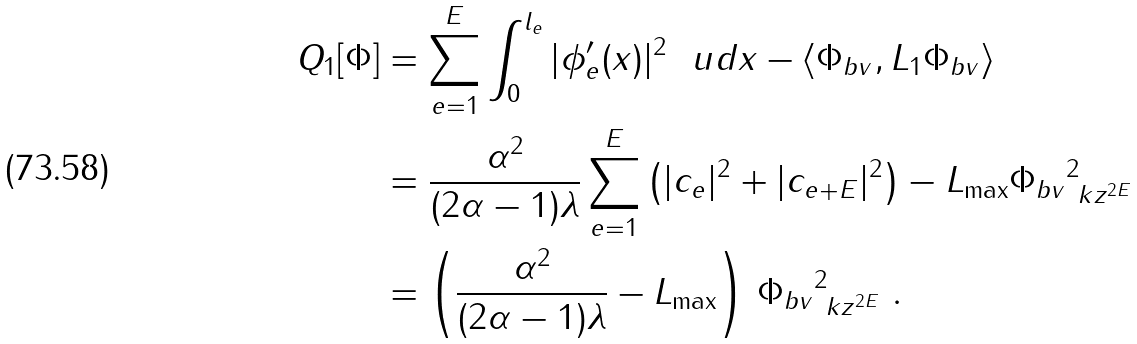<formula> <loc_0><loc_0><loc_500><loc_500>Q _ { 1 } [ \Phi ] & = \sum _ { e = 1 } ^ { E } \int _ { 0 } ^ { l _ { e } } | \phi ^ { \prime } _ { e } ( x ) | ^ { 2 } \ \ u d x - \langle \Phi _ { b v } , L _ { 1 } \Phi _ { b v } \rangle \\ & = \frac { \alpha ^ { 2 } } { ( 2 \alpha - 1 ) \lambda } \sum _ { e = 1 } ^ { E } \left ( | c _ { e } | ^ { 2 } + | c _ { e + E } | ^ { 2 } \right ) - L _ { \max } \| \Phi _ { b v } \| ^ { 2 } _ { \ k z ^ { 2 E } } \\ & = \left ( \frac { \alpha ^ { 2 } } { ( 2 \alpha - 1 ) \lambda } - L _ { \max } \right ) \, \| \Phi _ { b v } \| ^ { 2 } _ { \ k z ^ { 2 E } } \ .</formula> 